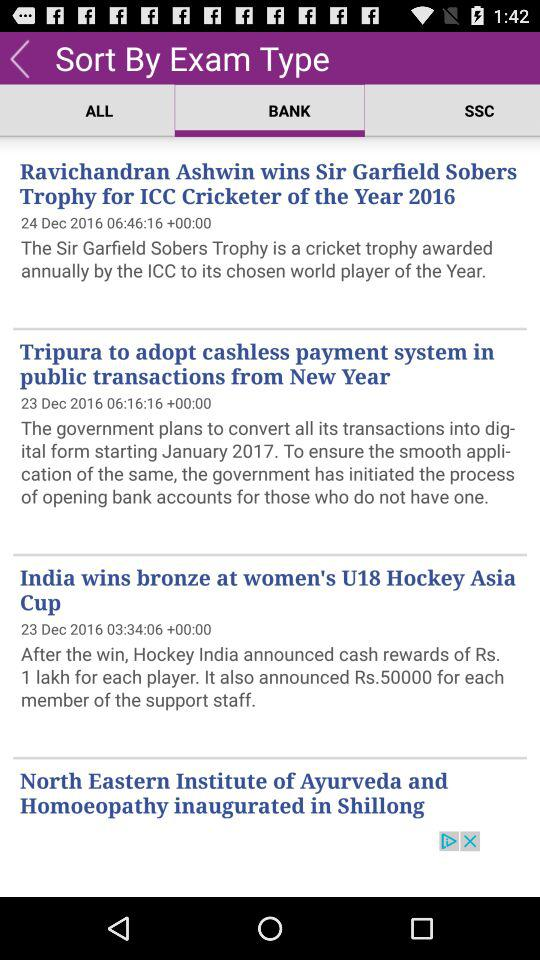Which tab is selected? The selected tab is Bank. 